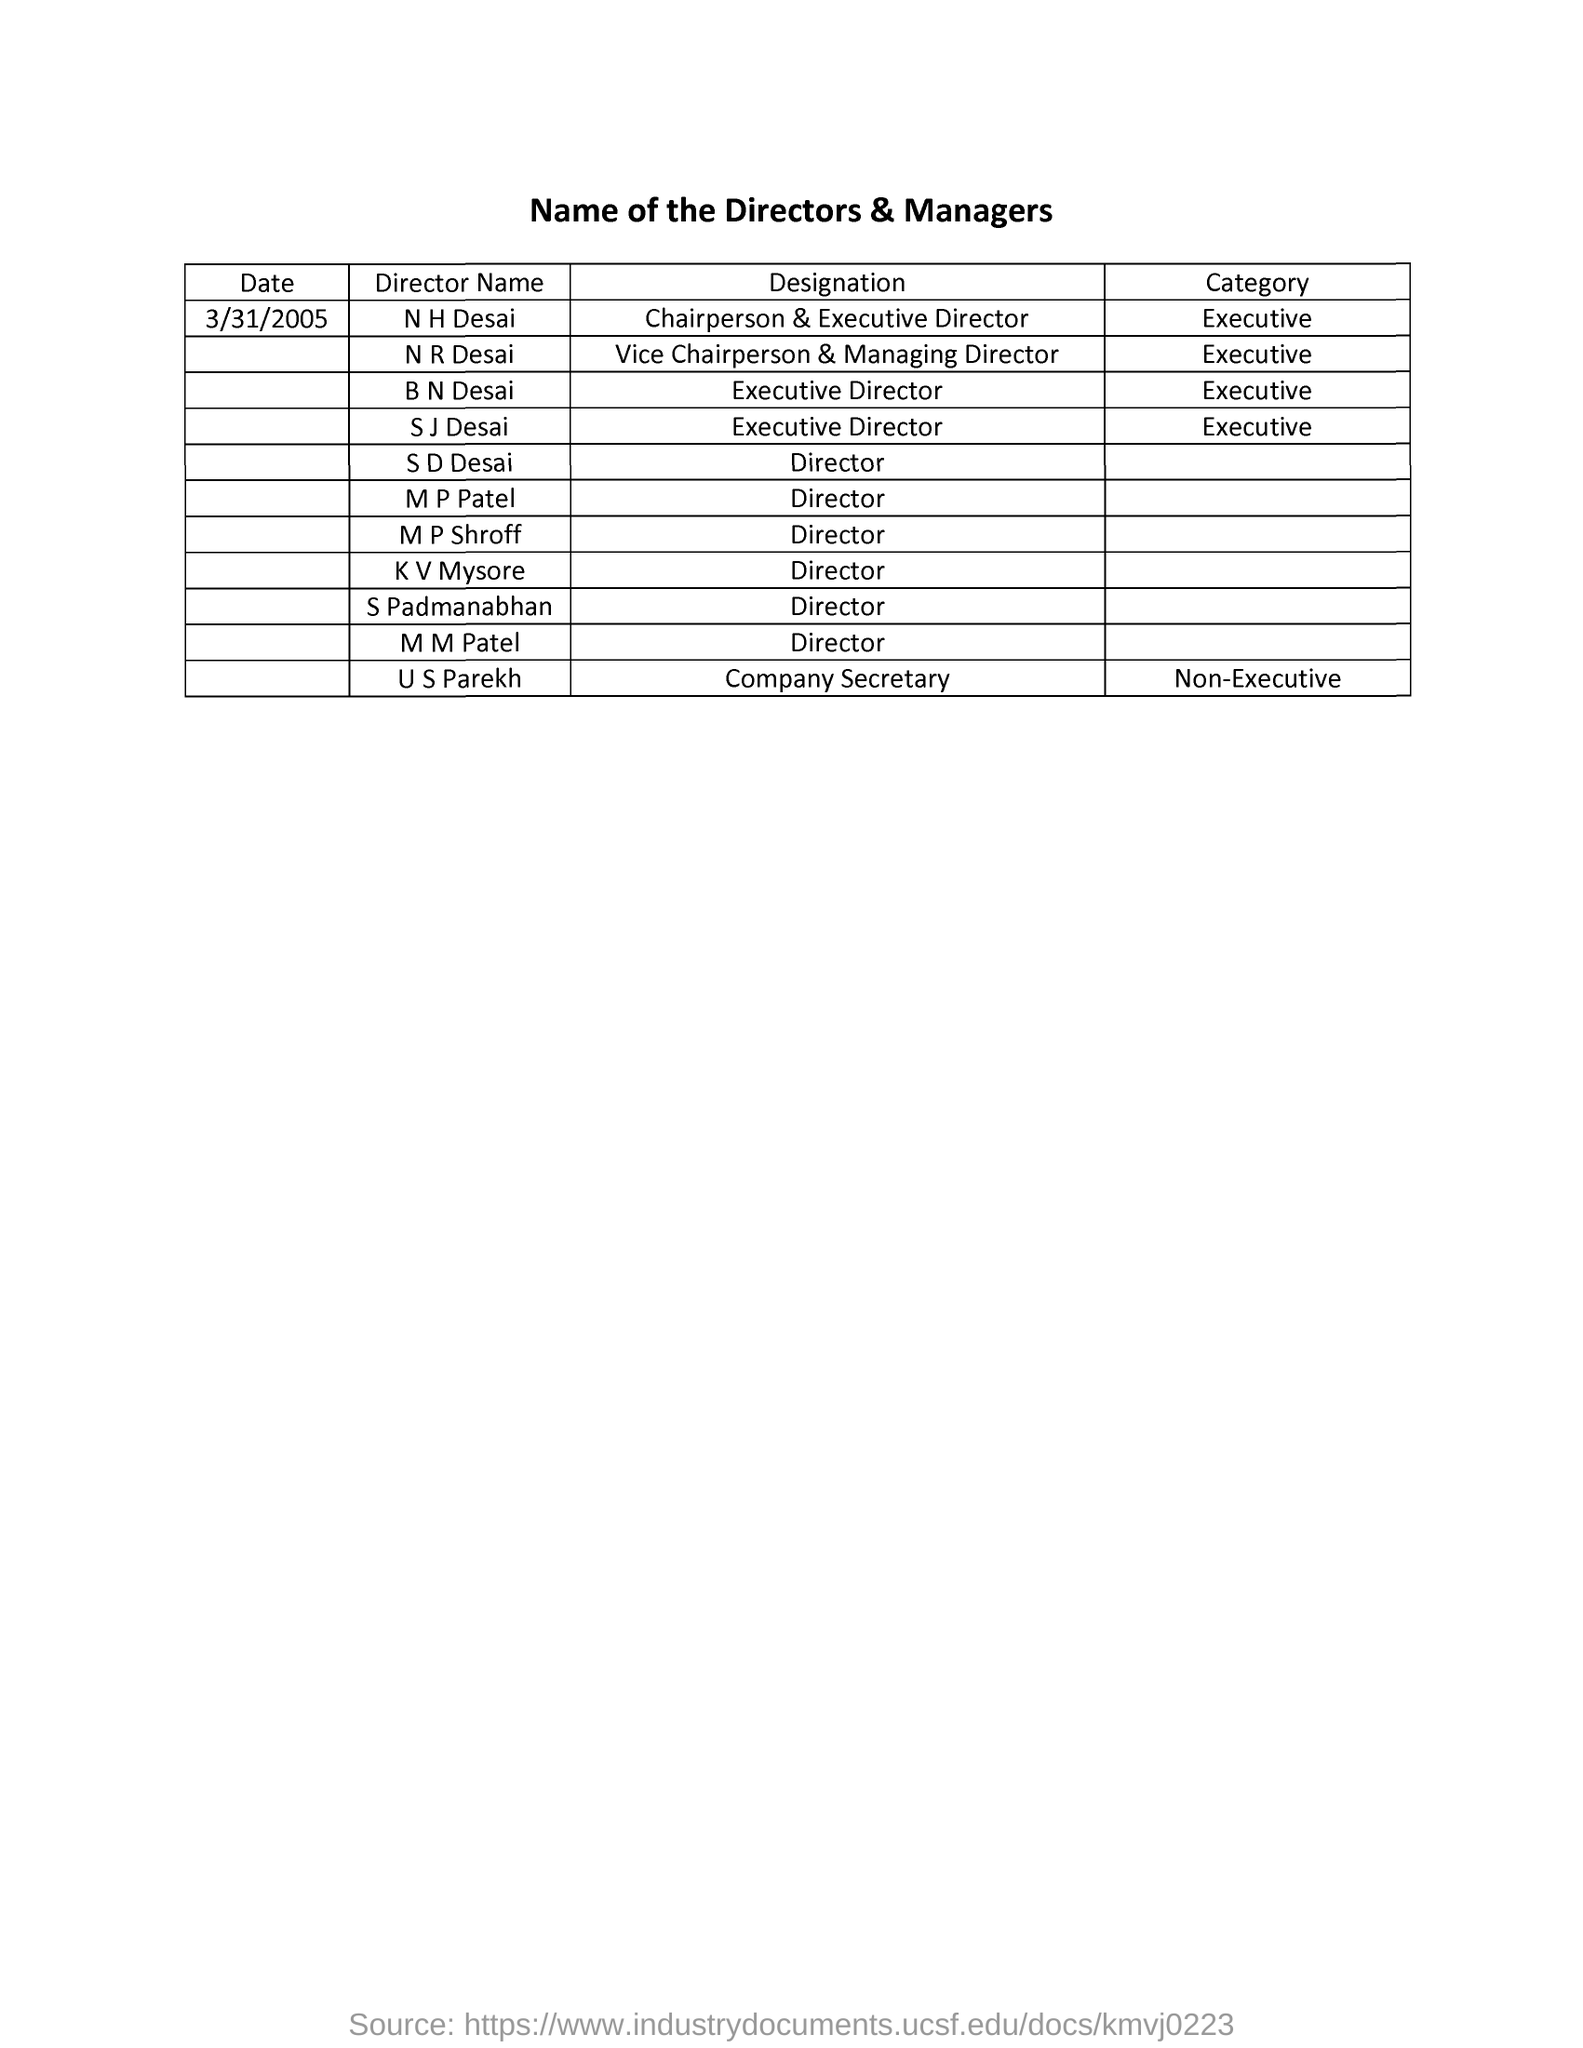How does the category 'Executive' differ from 'Non-Executive' in company roles? Executives are directly involved in the day-to-day management and decision-making processes of the company, often holding titles such as CEO, Director, or Vice President. Non-Executive roles, like Company Secretary listed in the image, typically involve governance and compliance oversight, advising and ensuring that the company adheres to legal and ethical standards without being involved in everyday managerial tasks. 